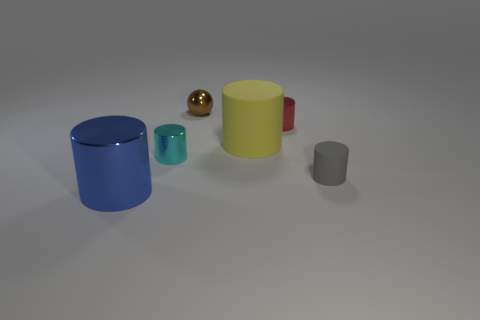How many things are balls or cylinders to the left of the red shiny cylinder?
Your answer should be compact. 4. There is a big yellow thing that is the same shape as the gray thing; what is it made of?
Your response must be concise. Rubber. Does the matte thing that is in front of the big yellow rubber object have the same shape as the red metallic object?
Ensure brevity in your answer.  Yes. Is the number of tiny cyan metal cylinders that are behind the brown metallic thing less than the number of tiny red metal cylinders that are to the right of the tiny rubber object?
Your response must be concise. No. How many other objects are there of the same shape as the cyan thing?
Your answer should be very brief. 4. What size is the matte cylinder right of the matte thing left of the cylinder right of the small red metallic cylinder?
Provide a succinct answer. Small. What number of yellow things are metal objects or large rubber things?
Keep it short and to the point. 1. What shape is the rubber thing that is in front of the big object that is right of the tiny cyan metallic object?
Your answer should be very brief. Cylinder. There is a metallic object in front of the small cyan metal thing; is it the same size as the rubber cylinder in front of the big yellow thing?
Offer a terse response. No. Are there any large balls made of the same material as the big blue cylinder?
Make the answer very short. No. 